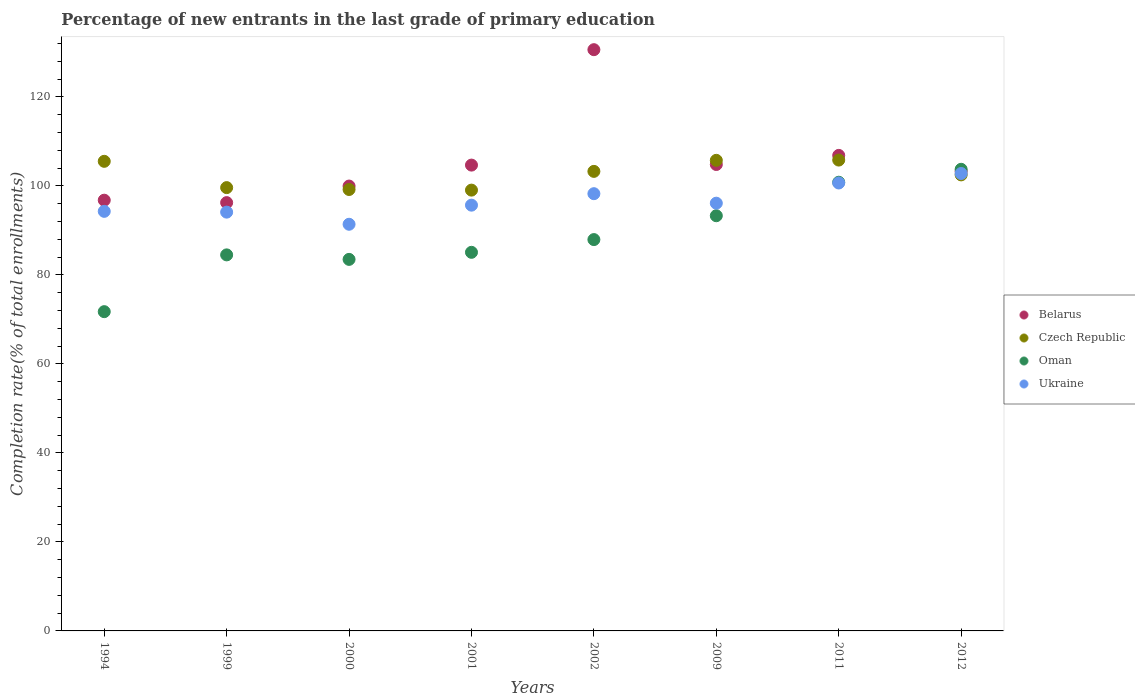Is the number of dotlines equal to the number of legend labels?
Your response must be concise. Yes. What is the percentage of new entrants in Oman in 2009?
Offer a very short reply. 93.29. Across all years, what is the maximum percentage of new entrants in Belarus?
Give a very brief answer. 130.61. Across all years, what is the minimum percentage of new entrants in Oman?
Provide a short and direct response. 71.74. In which year was the percentage of new entrants in Oman minimum?
Your response must be concise. 1994. What is the total percentage of new entrants in Belarus in the graph?
Offer a terse response. 843.21. What is the difference between the percentage of new entrants in Oman in 1999 and that in 2012?
Provide a succinct answer. -19.23. What is the difference between the percentage of new entrants in Belarus in 2000 and the percentage of new entrants in Ukraine in 2009?
Provide a succinct answer. 3.85. What is the average percentage of new entrants in Oman per year?
Your answer should be very brief. 88.82. In the year 2009, what is the difference between the percentage of new entrants in Oman and percentage of new entrants in Ukraine?
Offer a very short reply. -2.82. What is the ratio of the percentage of new entrants in Czech Republic in 2001 to that in 2002?
Give a very brief answer. 0.96. What is the difference between the highest and the second highest percentage of new entrants in Oman?
Your answer should be compact. 2.91. What is the difference between the highest and the lowest percentage of new entrants in Ukraine?
Your answer should be compact. 11.41. Is the sum of the percentage of new entrants in Belarus in 1994 and 2002 greater than the maximum percentage of new entrants in Czech Republic across all years?
Give a very brief answer. Yes. Is the percentage of new entrants in Belarus strictly greater than the percentage of new entrants in Oman over the years?
Provide a short and direct response. No. Does the graph contain any zero values?
Make the answer very short. No. Does the graph contain grids?
Provide a succinct answer. No. How are the legend labels stacked?
Keep it short and to the point. Vertical. What is the title of the graph?
Offer a very short reply. Percentage of new entrants in the last grade of primary education. Does "Maldives" appear as one of the legend labels in the graph?
Ensure brevity in your answer.  No. What is the label or title of the Y-axis?
Keep it short and to the point. Completion rate(% of total enrollments). What is the Completion rate(% of total enrollments) of Belarus in 1994?
Give a very brief answer. 96.79. What is the Completion rate(% of total enrollments) of Czech Republic in 1994?
Make the answer very short. 105.52. What is the Completion rate(% of total enrollments) of Oman in 1994?
Offer a terse response. 71.74. What is the Completion rate(% of total enrollments) in Ukraine in 1994?
Ensure brevity in your answer.  94.28. What is the Completion rate(% of total enrollments) of Belarus in 1999?
Provide a succinct answer. 96.24. What is the Completion rate(% of total enrollments) in Czech Republic in 1999?
Give a very brief answer. 99.61. What is the Completion rate(% of total enrollments) of Oman in 1999?
Ensure brevity in your answer.  84.5. What is the Completion rate(% of total enrollments) in Ukraine in 1999?
Keep it short and to the point. 94.1. What is the Completion rate(% of total enrollments) of Belarus in 2000?
Keep it short and to the point. 99.96. What is the Completion rate(% of total enrollments) of Czech Republic in 2000?
Offer a terse response. 99.19. What is the Completion rate(% of total enrollments) in Oman in 2000?
Keep it short and to the point. 83.49. What is the Completion rate(% of total enrollments) in Ukraine in 2000?
Your answer should be very brief. 91.38. What is the Completion rate(% of total enrollments) in Belarus in 2001?
Your response must be concise. 104.67. What is the Completion rate(% of total enrollments) of Czech Republic in 2001?
Provide a short and direct response. 99.05. What is the Completion rate(% of total enrollments) of Oman in 2001?
Your answer should be compact. 85.07. What is the Completion rate(% of total enrollments) in Ukraine in 2001?
Offer a very short reply. 95.67. What is the Completion rate(% of total enrollments) in Belarus in 2002?
Provide a short and direct response. 130.61. What is the Completion rate(% of total enrollments) in Czech Republic in 2002?
Provide a short and direct response. 103.26. What is the Completion rate(% of total enrollments) of Oman in 2002?
Offer a very short reply. 87.93. What is the Completion rate(% of total enrollments) of Ukraine in 2002?
Your response must be concise. 98.25. What is the Completion rate(% of total enrollments) of Belarus in 2009?
Offer a very short reply. 104.81. What is the Completion rate(% of total enrollments) in Czech Republic in 2009?
Offer a very short reply. 105.74. What is the Completion rate(% of total enrollments) of Oman in 2009?
Your response must be concise. 93.29. What is the Completion rate(% of total enrollments) in Ukraine in 2009?
Offer a very short reply. 96.11. What is the Completion rate(% of total enrollments) of Belarus in 2011?
Provide a succinct answer. 106.85. What is the Completion rate(% of total enrollments) in Czech Republic in 2011?
Provide a succinct answer. 105.8. What is the Completion rate(% of total enrollments) in Oman in 2011?
Offer a very short reply. 100.82. What is the Completion rate(% of total enrollments) of Ukraine in 2011?
Offer a very short reply. 100.65. What is the Completion rate(% of total enrollments) of Belarus in 2012?
Your answer should be very brief. 103.27. What is the Completion rate(% of total enrollments) of Czech Republic in 2012?
Offer a very short reply. 102.47. What is the Completion rate(% of total enrollments) in Oman in 2012?
Provide a succinct answer. 103.73. What is the Completion rate(% of total enrollments) of Ukraine in 2012?
Your response must be concise. 102.78. Across all years, what is the maximum Completion rate(% of total enrollments) in Belarus?
Offer a terse response. 130.61. Across all years, what is the maximum Completion rate(% of total enrollments) of Czech Republic?
Ensure brevity in your answer.  105.8. Across all years, what is the maximum Completion rate(% of total enrollments) in Oman?
Keep it short and to the point. 103.73. Across all years, what is the maximum Completion rate(% of total enrollments) in Ukraine?
Keep it short and to the point. 102.78. Across all years, what is the minimum Completion rate(% of total enrollments) of Belarus?
Keep it short and to the point. 96.24. Across all years, what is the minimum Completion rate(% of total enrollments) of Czech Republic?
Keep it short and to the point. 99.05. Across all years, what is the minimum Completion rate(% of total enrollments) in Oman?
Make the answer very short. 71.74. Across all years, what is the minimum Completion rate(% of total enrollments) in Ukraine?
Your answer should be very brief. 91.38. What is the total Completion rate(% of total enrollments) in Belarus in the graph?
Provide a succinct answer. 843.21. What is the total Completion rate(% of total enrollments) in Czech Republic in the graph?
Offer a terse response. 820.66. What is the total Completion rate(% of total enrollments) of Oman in the graph?
Provide a succinct answer. 710.58. What is the total Completion rate(% of total enrollments) of Ukraine in the graph?
Offer a very short reply. 773.23. What is the difference between the Completion rate(% of total enrollments) of Belarus in 1994 and that in 1999?
Provide a short and direct response. 0.55. What is the difference between the Completion rate(% of total enrollments) of Czech Republic in 1994 and that in 1999?
Provide a succinct answer. 5.91. What is the difference between the Completion rate(% of total enrollments) of Oman in 1994 and that in 1999?
Keep it short and to the point. -12.76. What is the difference between the Completion rate(% of total enrollments) of Ukraine in 1994 and that in 1999?
Your response must be concise. 0.18. What is the difference between the Completion rate(% of total enrollments) of Belarus in 1994 and that in 2000?
Ensure brevity in your answer.  -3.18. What is the difference between the Completion rate(% of total enrollments) in Czech Republic in 1994 and that in 2000?
Provide a succinct answer. 6.33. What is the difference between the Completion rate(% of total enrollments) in Oman in 1994 and that in 2000?
Offer a very short reply. -11.75. What is the difference between the Completion rate(% of total enrollments) of Ukraine in 1994 and that in 2000?
Your answer should be compact. 2.9. What is the difference between the Completion rate(% of total enrollments) of Belarus in 1994 and that in 2001?
Make the answer very short. -7.89. What is the difference between the Completion rate(% of total enrollments) in Czech Republic in 1994 and that in 2001?
Provide a succinct answer. 6.47. What is the difference between the Completion rate(% of total enrollments) in Oman in 1994 and that in 2001?
Your answer should be compact. -13.34. What is the difference between the Completion rate(% of total enrollments) of Ukraine in 1994 and that in 2001?
Offer a very short reply. -1.39. What is the difference between the Completion rate(% of total enrollments) in Belarus in 1994 and that in 2002?
Your response must be concise. -33.82. What is the difference between the Completion rate(% of total enrollments) of Czech Republic in 1994 and that in 2002?
Your response must be concise. 2.26. What is the difference between the Completion rate(% of total enrollments) of Oman in 1994 and that in 2002?
Offer a very short reply. -16.2. What is the difference between the Completion rate(% of total enrollments) of Ukraine in 1994 and that in 2002?
Your answer should be very brief. -3.97. What is the difference between the Completion rate(% of total enrollments) of Belarus in 1994 and that in 2009?
Provide a succinct answer. -8.02. What is the difference between the Completion rate(% of total enrollments) in Czech Republic in 1994 and that in 2009?
Your answer should be compact. -0.22. What is the difference between the Completion rate(% of total enrollments) in Oman in 1994 and that in 2009?
Your answer should be compact. -21.56. What is the difference between the Completion rate(% of total enrollments) in Ukraine in 1994 and that in 2009?
Your answer should be very brief. -1.83. What is the difference between the Completion rate(% of total enrollments) in Belarus in 1994 and that in 2011?
Give a very brief answer. -10.07. What is the difference between the Completion rate(% of total enrollments) of Czech Republic in 1994 and that in 2011?
Offer a very short reply. -0.28. What is the difference between the Completion rate(% of total enrollments) in Oman in 1994 and that in 2011?
Your answer should be very brief. -29.08. What is the difference between the Completion rate(% of total enrollments) in Ukraine in 1994 and that in 2011?
Provide a short and direct response. -6.37. What is the difference between the Completion rate(% of total enrollments) of Belarus in 1994 and that in 2012?
Provide a short and direct response. -6.49. What is the difference between the Completion rate(% of total enrollments) in Czech Republic in 1994 and that in 2012?
Your answer should be very brief. 3.05. What is the difference between the Completion rate(% of total enrollments) in Oman in 1994 and that in 2012?
Give a very brief answer. -31.99. What is the difference between the Completion rate(% of total enrollments) in Ukraine in 1994 and that in 2012?
Ensure brevity in your answer.  -8.5. What is the difference between the Completion rate(% of total enrollments) of Belarus in 1999 and that in 2000?
Your answer should be compact. -3.72. What is the difference between the Completion rate(% of total enrollments) of Czech Republic in 1999 and that in 2000?
Provide a succinct answer. 0.42. What is the difference between the Completion rate(% of total enrollments) in Oman in 1999 and that in 2000?
Keep it short and to the point. 1.01. What is the difference between the Completion rate(% of total enrollments) in Ukraine in 1999 and that in 2000?
Your response must be concise. 2.73. What is the difference between the Completion rate(% of total enrollments) of Belarus in 1999 and that in 2001?
Offer a very short reply. -8.43. What is the difference between the Completion rate(% of total enrollments) in Czech Republic in 1999 and that in 2001?
Provide a short and direct response. 0.56. What is the difference between the Completion rate(% of total enrollments) in Oman in 1999 and that in 2001?
Your answer should be very brief. -0.58. What is the difference between the Completion rate(% of total enrollments) of Ukraine in 1999 and that in 2001?
Your response must be concise. -1.57. What is the difference between the Completion rate(% of total enrollments) of Belarus in 1999 and that in 2002?
Make the answer very short. -34.37. What is the difference between the Completion rate(% of total enrollments) of Czech Republic in 1999 and that in 2002?
Your answer should be very brief. -3.65. What is the difference between the Completion rate(% of total enrollments) of Oman in 1999 and that in 2002?
Offer a terse response. -3.44. What is the difference between the Completion rate(% of total enrollments) in Ukraine in 1999 and that in 2002?
Give a very brief answer. -4.15. What is the difference between the Completion rate(% of total enrollments) of Belarus in 1999 and that in 2009?
Keep it short and to the point. -8.57. What is the difference between the Completion rate(% of total enrollments) in Czech Republic in 1999 and that in 2009?
Offer a terse response. -6.13. What is the difference between the Completion rate(% of total enrollments) of Oman in 1999 and that in 2009?
Provide a short and direct response. -8.8. What is the difference between the Completion rate(% of total enrollments) of Ukraine in 1999 and that in 2009?
Make the answer very short. -2.01. What is the difference between the Completion rate(% of total enrollments) of Belarus in 1999 and that in 2011?
Provide a succinct answer. -10.61. What is the difference between the Completion rate(% of total enrollments) in Czech Republic in 1999 and that in 2011?
Make the answer very short. -6.19. What is the difference between the Completion rate(% of total enrollments) of Oman in 1999 and that in 2011?
Your answer should be very brief. -16.32. What is the difference between the Completion rate(% of total enrollments) of Ukraine in 1999 and that in 2011?
Ensure brevity in your answer.  -6.55. What is the difference between the Completion rate(% of total enrollments) of Belarus in 1999 and that in 2012?
Give a very brief answer. -7.04. What is the difference between the Completion rate(% of total enrollments) in Czech Republic in 1999 and that in 2012?
Offer a very short reply. -2.86. What is the difference between the Completion rate(% of total enrollments) in Oman in 1999 and that in 2012?
Your response must be concise. -19.23. What is the difference between the Completion rate(% of total enrollments) in Ukraine in 1999 and that in 2012?
Your response must be concise. -8.68. What is the difference between the Completion rate(% of total enrollments) in Belarus in 2000 and that in 2001?
Your answer should be very brief. -4.71. What is the difference between the Completion rate(% of total enrollments) in Czech Republic in 2000 and that in 2001?
Provide a succinct answer. 0.14. What is the difference between the Completion rate(% of total enrollments) of Oman in 2000 and that in 2001?
Give a very brief answer. -1.59. What is the difference between the Completion rate(% of total enrollments) of Ukraine in 2000 and that in 2001?
Offer a very short reply. -4.29. What is the difference between the Completion rate(% of total enrollments) of Belarus in 2000 and that in 2002?
Offer a terse response. -30.65. What is the difference between the Completion rate(% of total enrollments) in Czech Republic in 2000 and that in 2002?
Give a very brief answer. -4.07. What is the difference between the Completion rate(% of total enrollments) of Oman in 2000 and that in 2002?
Make the answer very short. -4.45. What is the difference between the Completion rate(% of total enrollments) of Ukraine in 2000 and that in 2002?
Ensure brevity in your answer.  -6.87. What is the difference between the Completion rate(% of total enrollments) in Belarus in 2000 and that in 2009?
Give a very brief answer. -4.85. What is the difference between the Completion rate(% of total enrollments) in Czech Republic in 2000 and that in 2009?
Your response must be concise. -6.55. What is the difference between the Completion rate(% of total enrollments) of Oman in 2000 and that in 2009?
Your response must be concise. -9.81. What is the difference between the Completion rate(% of total enrollments) in Ukraine in 2000 and that in 2009?
Offer a terse response. -4.74. What is the difference between the Completion rate(% of total enrollments) in Belarus in 2000 and that in 2011?
Keep it short and to the point. -6.89. What is the difference between the Completion rate(% of total enrollments) in Czech Republic in 2000 and that in 2011?
Ensure brevity in your answer.  -6.61. What is the difference between the Completion rate(% of total enrollments) in Oman in 2000 and that in 2011?
Offer a very short reply. -17.34. What is the difference between the Completion rate(% of total enrollments) of Ukraine in 2000 and that in 2011?
Keep it short and to the point. -9.28. What is the difference between the Completion rate(% of total enrollments) of Belarus in 2000 and that in 2012?
Offer a very short reply. -3.31. What is the difference between the Completion rate(% of total enrollments) of Czech Republic in 2000 and that in 2012?
Ensure brevity in your answer.  -3.29. What is the difference between the Completion rate(% of total enrollments) in Oman in 2000 and that in 2012?
Keep it short and to the point. -20.24. What is the difference between the Completion rate(% of total enrollments) in Ukraine in 2000 and that in 2012?
Offer a terse response. -11.4. What is the difference between the Completion rate(% of total enrollments) in Belarus in 2001 and that in 2002?
Your answer should be compact. -25.94. What is the difference between the Completion rate(% of total enrollments) in Czech Republic in 2001 and that in 2002?
Your response must be concise. -4.21. What is the difference between the Completion rate(% of total enrollments) of Oman in 2001 and that in 2002?
Your answer should be very brief. -2.86. What is the difference between the Completion rate(% of total enrollments) of Ukraine in 2001 and that in 2002?
Provide a succinct answer. -2.58. What is the difference between the Completion rate(% of total enrollments) in Belarus in 2001 and that in 2009?
Your response must be concise. -0.14. What is the difference between the Completion rate(% of total enrollments) in Czech Republic in 2001 and that in 2009?
Keep it short and to the point. -6.69. What is the difference between the Completion rate(% of total enrollments) in Oman in 2001 and that in 2009?
Give a very brief answer. -8.22. What is the difference between the Completion rate(% of total enrollments) of Ukraine in 2001 and that in 2009?
Provide a succinct answer. -0.44. What is the difference between the Completion rate(% of total enrollments) of Belarus in 2001 and that in 2011?
Provide a short and direct response. -2.18. What is the difference between the Completion rate(% of total enrollments) of Czech Republic in 2001 and that in 2011?
Offer a terse response. -6.75. What is the difference between the Completion rate(% of total enrollments) in Oman in 2001 and that in 2011?
Provide a short and direct response. -15.75. What is the difference between the Completion rate(% of total enrollments) of Ukraine in 2001 and that in 2011?
Give a very brief answer. -4.98. What is the difference between the Completion rate(% of total enrollments) of Belarus in 2001 and that in 2012?
Offer a terse response. 1.4. What is the difference between the Completion rate(% of total enrollments) of Czech Republic in 2001 and that in 2012?
Ensure brevity in your answer.  -3.42. What is the difference between the Completion rate(% of total enrollments) of Oman in 2001 and that in 2012?
Make the answer very short. -18.66. What is the difference between the Completion rate(% of total enrollments) in Ukraine in 2001 and that in 2012?
Your answer should be compact. -7.11. What is the difference between the Completion rate(% of total enrollments) in Belarus in 2002 and that in 2009?
Provide a short and direct response. 25.8. What is the difference between the Completion rate(% of total enrollments) in Czech Republic in 2002 and that in 2009?
Make the answer very short. -2.48. What is the difference between the Completion rate(% of total enrollments) of Oman in 2002 and that in 2009?
Keep it short and to the point. -5.36. What is the difference between the Completion rate(% of total enrollments) in Ukraine in 2002 and that in 2009?
Your answer should be very brief. 2.13. What is the difference between the Completion rate(% of total enrollments) of Belarus in 2002 and that in 2011?
Offer a very short reply. 23.76. What is the difference between the Completion rate(% of total enrollments) of Czech Republic in 2002 and that in 2011?
Provide a short and direct response. -2.54. What is the difference between the Completion rate(% of total enrollments) in Oman in 2002 and that in 2011?
Keep it short and to the point. -12.89. What is the difference between the Completion rate(% of total enrollments) in Ukraine in 2002 and that in 2011?
Offer a very short reply. -2.4. What is the difference between the Completion rate(% of total enrollments) in Belarus in 2002 and that in 2012?
Your answer should be compact. 27.33. What is the difference between the Completion rate(% of total enrollments) in Czech Republic in 2002 and that in 2012?
Make the answer very short. 0.79. What is the difference between the Completion rate(% of total enrollments) of Oman in 2002 and that in 2012?
Make the answer very short. -15.8. What is the difference between the Completion rate(% of total enrollments) in Ukraine in 2002 and that in 2012?
Offer a terse response. -4.53. What is the difference between the Completion rate(% of total enrollments) in Belarus in 2009 and that in 2011?
Your answer should be compact. -2.04. What is the difference between the Completion rate(% of total enrollments) in Czech Republic in 2009 and that in 2011?
Provide a short and direct response. -0.06. What is the difference between the Completion rate(% of total enrollments) in Oman in 2009 and that in 2011?
Your answer should be compact. -7.53. What is the difference between the Completion rate(% of total enrollments) in Ukraine in 2009 and that in 2011?
Your response must be concise. -4.54. What is the difference between the Completion rate(% of total enrollments) in Belarus in 2009 and that in 2012?
Give a very brief answer. 1.53. What is the difference between the Completion rate(% of total enrollments) in Czech Republic in 2009 and that in 2012?
Your answer should be very brief. 3.27. What is the difference between the Completion rate(% of total enrollments) in Oman in 2009 and that in 2012?
Provide a short and direct response. -10.44. What is the difference between the Completion rate(% of total enrollments) in Ukraine in 2009 and that in 2012?
Offer a terse response. -6.67. What is the difference between the Completion rate(% of total enrollments) in Belarus in 2011 and that in 2012?
Your answer should be very brief. 3.58. What is the difference between the Completion rate(% of total enrollments) of Czech Republic in 2011 and that in 2012?
Provide a succinct answer. 3.33. What is the difference between the Completion rate(% of total enrollments) of Oman in 2011 and that in 2012?
Ensure brevity in your answer.  -2.91. What is the difference between the Completion rate(% of total enrollments) of Ukraine in 2011 and that in 2012?
Offer a terse response. -2.13. What is the difference between the Completion rate(% of total enrollments) of Belarus in 1994 and the Completion rate(% of total enrollments) of Czech Republic in 1999?
Ensure brevity in your answer.  -2.83. What is the difference between the Completion rate(% of total enrollments) of Belarus in 1994 and the Completion rate(% of total enrollments) of Oman in 1999?
Your answer should be very brief. 12.29. What is the difference between the Completion rate(% of total enrollments) in Belarus in 1994 and the Completion rate(% of total enrollments) in Ukraine in 1999?
Ensure brevity in your answer.  2.68. What is the difference between the Completion rate(% of total enrollments) in Czech Republic in 1994 and the Completion rate(% of total enrollments) in Oman in 1999?
Make the answer very short. 21.02. What is the difference between the Completion rate(% of total enrollments) in Czech Republic in 1994 and the Completion rate(% of total enrollments) in Ukraine in 1999?
Your answer should be very brief. 11.42. What is the difference between the Completion rate(% of total enrollments) in Oman in 1994 and the Completion rate(% of total enrollments) in Ukraine in 1999?
Offer a very short reply. -22.36. What is the difference between the Completion rate(% of total enrollments) of Belarus in 1994 and the Completion rate(% of total enrollments) of Czech Republic in 2000?
Keep it short and to the point. -2.4. What is the difference between the Completion rate(% of total enrollments) in Belarus in 1994 and the Completion rate(% of total enrollments) in Oman in 2000?
Your response must be concise. 13.3. What is the difference between the Completion rate(% of total enrollments) in Belarus in 1994 and the Completion rate(% of total enrollments) in Ukraine in 2000?
Provide a short and direct response. 5.41. What is the difference between the Completion rate(% of total enrollments) in Czech Republic in 1994 and the Completion rate(% of total enrollments) in Oman in 2000?
Make the answer very short. 22.03. What is the difference between the Completion rate(% of total enrollments) of Czech Republic in 1994 and the Completion rate(% of total enrollments) of Ukraine in 2000?
Offer a very short reply. 14.14. What is the difference between the Completion rate(% of total enrollments) in Oman in 1994 and the Completion rate(% of total enrollments) in Ukraine in 2000?
Keep it short and to the point. -19.64. What is the difference between the Completion rate(% of total enrollments) in Belarus in 1994 and the Completion rate(% of total enrollments) in Czech Republic in 2001?
Ensure brevity in your answer.  -2.26. What is the difference between the Completion rate(% of total enrollments) in Belarus in 1994 and the Completion rate(% of total enrollments) in Oman in 2001?
Give a very brief answer. 11.71. What is the difference between the Completion rate(% of total enrollments) in Belarus in 1994 and the Completion rate(% of total enrollments) in Ukraine in 2001?
Provide a short and direct response. 1.12. What is the difference between the Completion rate(% of total enrollments) in Czech Republic in 1994 and the Completion rate(% of total enrollments) in Oman in 2001?
Your response must be concise. 20.45. What is the difference between the Completion rate(% of total enrollments) in Czech Republic in 1994 and the Completion rate(% of total enrollments) in Ukraine in 2001?
Keep it short and to the point. 9.85. What is the difference between the Completion rate(% of total enrollments) in Oman in 1994 and the Completion rate(% of total enrollments) in Ukraine in 2001?
Your response must be concise. -23.93. What is the difference between the Completion rate(% of total enrollments) in Belarus in 1994 and the Completion rate(% of total enrollments) in Czech Republic in 2002?
Give a very brief answer. -6.47. What is the difference between the Completion rate(% of total enrollments) in Belarus in 1994 and the Completion rate(% of total enrollments) in Oman in 2002?
Offer a very short reply. 8.85. What is the difference between the Completion rate(% of total enrollments) of Belarus in 1994 and the Completion rate(% of total enrollments) of Ukraine in 2002?
Keep it short and to the point. -1.46. What is the difference between the Completion rate(% of total enrollments) of Czech Republic in 1994 and the Completion rate(% of total enrollments) of Oman in 2002?
Your answer should be very brief. 17.59. What is the difference between the Completion rate(% of total enrollments) of Czech Republic in 1994 and the Completion rate(% of total enrollments) of Ukraine in 2002?
Give a very brief answer. 7.27. What is the difference between the Completion rate(% of total enrollments) of Oman in 1994 and the Completion rate(% of total enrollments) of Ukraine in 2002?
Keep it short and to the point. -26.51. What is the difference between the Completion rate(% of total enrollments) of Belarus in 1994 and the Completion rate(% of total enrollments) of Czech Republic in 2009?
Give a very brief answer. -8.96. What is the difference between the Completion rate(% of total enrollments) of Belarus in 1994 and the Completion rate(% of total enrollments) of Oman in 2009?
Offer a very short reply. 3.49. What is the difference between the Completion rate(% of total enrollments) of Belarus in 1994 and the Completion rate(% of total enrollments) of Ukraine in 2009?
Make the answer very short. 0.67. What is the difference between the Completion rate(% of total enrollments) of Czech Republic in 1994 and the Completion rate(% of total enrollments) of Oman in 2009?
Provide a short and direct response. 12.23. What is the difference between the Completion rate(% of total enrollments) in Czech Republic in 1994 and the Completion rate(% of total enrollments) in Ukraine in 2009?
Provide a succinct answer. 9.41. What is the difference between the Completion rate(% of total enrollments) in Oman in 1994 and the Completion rate(% of total enrollments) in Ukraine in 2009?
Your answer should be very brief. -24.38. What is the difference between the Completion rate(% of total enrollments) in Belarus in 1994 and the Completion rate(% of total enrollments) in Czech Republic in 2011?
Ensure brevity in your answer.  -9.02. What is the difference between the Completion rate(% of total enrollments) of Belarus in 1994 and the Completion rate(% of total enrollments) of Oman in 2011?
Provide a short and direct response. -4.04. What is the difference between the Completion rate(% of total enrollments) in Belarus in 1994 and the Completion rate(% of total enrollments) in Ukraine in 2011?
Your response must be concise. -3.87. What is the difference between the Completion rate(% of total enrollments) of Czech Republic in 1994 and the Completion rate(% of total enrollments) of Oman in 2011?
Your answer should be very brief. 4.7. What is the difference between the Completion rate(% of total enrollments) in Czech Republic in 1994 and the Completion rate(% of total enrollments) in Ukraine in 2011?
Provide a succinct answer. 4.87. What is the difference between the Completion rate(% of total enrollments) of Oman in 1994 and the Completion rate(% of total enrollments) of Ukraine in 2011?
Offer a very short reply. -28.91. What is the difference between the Completion rate(% of total enrollments) of Belarus in 1994 and the Completion rate(% of total enrollments) of Czech Republic in 2012?
Your answer should be very brief. -5.69. What is the difference between the Completion rate(% of total enrollments) in Belarus in 1994 and the Completion rate(% of total enrollments) in Oman in 2012?
Your answer should be very brief. -6.94. What is the difference between the Completion rate(% of total enrollments) of Belarus in 1994 and the Completion rate(% of total enrollments) of Ukraine in 2012?
Your answer should be very brief. -6. What is the difference between the Completion rate(% of total enrollments) in Czech Republic in 1994 and the Completion rate(% of total enrollments) in Oman in 2012?
Give a very brief answer. 1.79. What is the difference between the Completion rate(% of total enrollments) of Czech Republic in 1994 and the Completion rate(% of total enrollments) of Ukraine in 2012?
Provide a short and direct response. 2.74. What is the difference between the Completion rate(% of total enrollments) in Oman in 1994 and the Completion rate(% of total enrollments) in Ukraine in 2012?
Keep it short and to the point. -31.04. What is the difference between the Completion rate(% of total enrollments) in Belarus in 1999 and the Completion rate(% of total enrollments) in Czech Republic in 2000?
Your answer should be compact. -2.95. What is the difference between the Completion rate(% of total enrollments) in Belarus in 1999 and the Completion rate(% of total enrollments) in Oman in 2000?
Provide a succinct answer. 12.75. What is the difference between the Completion rate(% of total enrollments) of Belarus in 1999 and the Completion rate(% of total enrollments) of Ukraine in 2000?
Ensure brevity in your answer.  4.86. What is the difference between the Completion rate(% of total enrollments) of Czech Republic in 1999 and the Completion rate(% of total enrollments) of Oman in 2000?
Provide a short and direct response. 16.13. What is the difference between the Completion rate(% of total enrollments) in Czech Republic in 1999 and the Completion rate(% of total enrollments) in Ukraine in 2000?
Your answer should be compact. 8.24. What is the difference between the Completion rate(% of total enrollments) of Oman in 1999 and the Completion rate(% of total enrollments) of Ukraine in 2000?
Offer a very short reply. -6.88. What is the difference between the Completion rate(% of total enrollments) in Belarus in 1999 and the Completion rate(% of total enrollments) in Czech Republic in 2001?
Your answer should be very brief. -2.81. What is the difference between the Completion rate(% of total enrollments) of Belarus in 1999 and the Completion rate(% of total enrollments) of Oman in 2001?
Ensure brevity in your answer.  11.16. What is the difference between the Completion rate(% of total enrollments) of Belarus in 1999 and the Completion rate(% of total enrollments) of Ukraine in 2001?
Provide a succinct answer. 0.57. What is the difference between the Completion rate(% of total enrollments) in Czech Republic in 1999 and the Completion rate(% of total enrollments) in Oman in 2001?
Give a very brief answer. 14.54. What is the difference between the Completion rate(% of total enrollments) of Czech Republic in 1999 and the Completion rate(% of total enrollments) of Ukraine in 2001?
Your answer should be compact. 3.94. What is the difference between the Completion rate(% of total enrollments) in Oman in 1999 and the Completion rate(% of total enrollments) in Ukraine in 2001?
Provide a short and direct response. -11.17. What is the difference between the Completion rate(% of total enrollments) of Belarus in 1999 and the Completion rate(% of total enrollments) of Czech Republic in 2002?
Provide a succinct answer. -7.02. What is the difference between the Completion rate(% of total enrollments) of Belarus in 1999 and the Completion rate(% of total enrollments) of Oman in 2002?
Your answer should be compact. 8.3. What is the difference between the Completion rate(% of total enrollments) in Belarus in 1999 and the Completion rate(% of total enrollments) in Ukraine in 2002?
Ensure brevity in your answer.  -2.01. What is the difference between the Completion rate(% of total enrollments) of Czech Republic in 1999 and the Completion rate(% of total enrollments) of Oman in 2002?
Offer a very short reply. 11.68. What is the difference between the Completion rate(% of total enrollments) of Czech Republic in 1999 and the Completion rate(% of total enrollments) of Ukraine in 2002?
Keep it short and to the point. 1.36. What is the difference between the Completion rate(% of total enrollments) in Oman in 1999 and the Completion rate(% of total enrollments) in Ukraine in 2002?
Provide a short and direct response. -13.75. What is the difference between the Completion rate(% of total enrollments) in Belarus in 1999 and the Completion rate(% of total enrollments) in Czech Republic in 2009?
Ensure brevity in your answer.  -9.51. What is the difference between the Completion rate(% of total enrollments) of Belarus in 1999 and the Completion rate(% of total enrollments) of Oman in 2009?
Make the answer very short. 2.94. What is the difference between the Completion rate(% of total enrollments) in Belarus in 1999 and the Completion rate(% of total enrollments) in Ukraine in 2009?
Your response must be concise. 0.12. What is the difference between the Completion rate(% of total enrollments) in Czech Republic in 1999 and the Completion rate(% of total enrollments) in Oman in 2009?
Your response must be concise. 6.32. What is the difference between the Completion rate(% of total enrollments) of Czech Republic in 1999 and the Completion rate(% of total enrollments) of Ukraine in 2009?
Your response must be concise. 3.5. What is the difference between the Completion rate(% of total enrollments) of Oman in 1999 and the Completion rate(% of total enrollments) of Ukraine in 2009?
Your response must be concise. -11.62. What is the difference between the Completion rate(% of total enrollments) in Belarus in 1999 and the Completion rate(% of total enrollments) in Czech Republic in 2011?
Provide a short and direct response. -9.56. What is the difference between the Completion rate(% of total enrollments) of Belarus in 1999 and the Completion rate(% of total enrollments) of Oman in 2011?
Give a very brief answer. -4.58. What is the difference between the Completion rate(% of total enrollments) of Belarus in 1999 and the Completion rate(% of total enrollments) of Ukraine in 2011?
Make the answer very short. -4.41. What is the difference between the Completion rate(% of total enrollments) in Czech Republic in 1999 and the Completion rate(% of total enrollments) in Oman in 2011?
Your answer should be very brief. -1.21. What is the difference between the Completion rate(% of total enrollments) of Czech Republic in 1999 and the Completion rate(% of total enrollments) of Ukraine in 2011?
Your answer should be very brief. -1.04. What is the difference between the Completion rate(% of total enrollments) in Oman in 1999 and the Completion rate(% of total enrollments) in Ukraine in 2011?
Give a very brief answer. -16.15. What is the difference between the Completion rate(% of total enrollments) in Belarus in 1999 and the Completion rate(% of total enrollments) in Czech Republic in 2012?
Your answer should be very brief. -6.24. What is the difference between the Completion rate(% of total enrollments) of Belarus in 1999 and the Completion rate(% of total enrollments) of Oman in 2012?
Ensure brevity in your answer.  -7.49. What is the difference between the Completion rate(% of total enrollments) in Belarus in 1999 and the Completion rate(% of total enrollments) in Ukraine in 2012?
Offer a terse response. -6.54. What is the difference between the Completion rate(% of total enrollments) in Czech Republic in 1999 and the Completion rate(% of total enrollments) in Oman in 2012?
Your answer should be compact. -4.12. What is the difference between the Completion rate(% of total enrollments) of Czech Republic in 1999 and the Completion rate(% of total enrollments) of Ukraine in 2012?
Your answer should be very brief. -3.17. What is the difference between the Completion rate(% of total enrollments) in Oman in 1999 and the Completion rate(% of total enrollments) in Ukraine in 2012?
Give a very brief answer. -18.28. What is the difference between the Completion rate(% of total enrollments) of Belarus in 2000 and the Completion rate(% of total enrollments) of Czech Republic in 2001?
Give a very brief answer. 0.91. What is the difference between the Completion rate(% of total enrollments) of Belarus in 2000 and the Completion rate(% of total enrollments) of Oman in 2001?
Give a very brief answer. 14.89. What is the difference between the Completion rate(% of total enrollments) in Belarus in 2000 and the Completion rate(% of total enrollments) in Ukraine in 2001?
Your response must be concise. 4.29. What is the difference between the Completion rate(% of total enrollments) in Czech Republic in 2000 and the Completion rate(% of total enrollments) in Oman in 2001?
Provide a short and direct response. 14.12. What is the difference between the Completion rate(% of total enrollments) of Czech Republic in 2000 and the Completion rate(% of total enrollments) of Ukraine in 2001?
Your response must be concise. 3.52. What is the difference between the Completion rate(% of total enrollments) in Oman in 2000 and the Completion rate(% of total enrollments) in Ukraine in 2001?
Offer a terse response. -12.19. What is the difference between the Completion rate(% of total enrollments) of Belarus in 2000 and the Completion rate(% of total enrollments) of Czech Republic in 2002?
Your answer should be compact. -3.3. What is the difference between the Completion rate(% of total enrollments) in Belarus in 2000 and the Completion rate(% of total enrollments) in Oman in 2002?
Provide a succinct answer. 12.03. What is the difference between the Completion rate(% of total enrollments) in Belarus in 2000 and the Completion rate(% of total enrollments) in Ukraine in 2002?
Your answer should be compact. 1.71. What is the difference between the Completion rate(% of total enrollments) of Czech Republic in 2000 and the Completion rate(% of total enrollments) of Oman in 2002?
Keep it short and to the point. 11.26. What is the difference between the Completion rate(% of total enrollments) in Czech Republic in 2000 and the Completion rate(% of total enrollments) in Ukraine in 2002?
Give a very brief answer. 0.94. What is the difference between the Completion rate(% of total enrollments) in Oman in 2000 and the Completion rate(% of total enrollments) in Ukraine in 2002?
Provide a succinct answer. -14.76. What is the difference between the Completion rate(% of total enrollments) in Belarus in 2000 and the Completion rate(% of total enrollments) in Czech Republic in 2009?
Provide a short and direct response. -5.78. What is the difference between the Completion rate(% of total enrollments) of Belarus in 2000 and the Completion rate(% of total enrollments) of Oman in 2009?
Your answer should be compact. 6.67. What is the difference between the Completion rate(% of total enrollments) in Belarus in 2000 and the Completion rate(% of total enrollments) in Ukraine in 2009?
Offer a terse response. 3.85. What is the difference between the Completion rate(% of total enrollments) in Czech Republic in 2000 and the Completion rate(% of total enrollments) in Oman in 2009?
Your answer should be compact. 5.9. What is the difference between the Completion rate(% of total enrollments) in Czech Republic in 2000 and the Completion rate(% of total enrollments) in Ukraine in 2009?
Keep it short and to the point. 3.08. What is the difference between the Completion rate(% of total enrollments) of Oman in 2000 and the Completion rate(% of total enrollments) of Ukraine in 2009?
Give a very brief answer. -12.63. What is the difference between the Completion rate(% of total enrollments) of Belarus in 2000 and the Completion rate(% of total enrollments) of Czech Republic in 2011?
Make the answer very short. -5.84. What is the difference between the Completion rate(% of total enrollments) in Belarus in 2000 and the Completion rate(% of total enrollments) in Oman in 2011?
Your response must be concise. -0.86. What is the difference between the Completion rate(% of total enrollments) of Belarus in 2000 and the Completion rate(% of total enrollments) of Ukraine in 2011?
Offer a terse response. -0.69. What is the difference between the Completion rate(% of total enrollments) in Czech Republic in 2000 and the Completion rate(% of total enrollments) in Oman in 2011?
Provide a succinct answer. -1.63. What is the difference between the Completion rate(% of total enrollments) in Czech Republic in 2000 and the Completion rate(% of total enrollments) in Ukraine in 2011?
Make the answer very short. -1.46. What is the difference between the Completion rate(% of total enrollments) in Oman in 2000 and the Completion rate(% of total enrollments) in Ukraine in 2011?
Your answer should be very brief. -17.17. What is the difference between the Completion rate(% of total enrollments) in Belarus in 2000 and the Completion rate(% of total enrollments) in Czech Republic in 2012?
Provide a short and direct response. -2.51. What is the difference between the Completion rate(% of total enrollments) of Belarus in 2000 and the Completion rate(% of total enrollments) of Oman in 2012?
Your response must be concise. -3.77. What is the difference between the Completion rate(% of total enrollments) in Belarus in 2000 and the Completion rate(% of total enrollments) in Ukraine in 2012?
Make the answer very short. -2.82. What is the difference between the Completion rate(% of total enrollments) of Czech Republic in 2000 and the Completion rate(% of total enrollments) of Oman in 2012?
Offer a terse response. -4.54. What is the difference between the Completion rate(% of total enrollments) in Czech Republic in 2000 and the Completion rate(% of total enrollments) in Ukraine in 2012?
Make the answer very short. -3.59. What is the difference between the Completion rate(% of total enrollments) in Oman in 2000 and the Completion rate(% of total enrollments) in Ukraine in 2012?
Provide a succinct answer. -19.3. What is the difference between the Completion rate(% of total enrollments) in Belarus in 2001 and the Completion rate(% of total enrollments) in Czech Republic in 2002?
Make the answer very short. 1.41. What is the difference between the Completion rate(% of total enrollments) of Belarus in 2001 and the Completion rate(% of total enrollments) of Oman in 2002?
Give a very brief answer. 16.74. What is the difference between the Completion rate(% of total enrollments) in Belarus in 2001 and the Completion rate(% of total enrollments) in Ukraine in 2002?
Provide a succinct answer. 6.42. What is the difference between the Completion rate(% of total enrollments) in Czech Republic in 2001 and the Completion rate(% of total enrollments) in Oman in 2002?
Keep it short and to the point. 11.12. What is the difference between the Completion rate(% of total enrollments) in Czech Republic in 2001 and the Completion rate(% of total enrollments) in Ukraine in 2002?
Provide a short and direct response. 0.8. What is the difference between the Completion rate(% of total enrollments) in Oman in 2001 and the Completion rate(% of total enrollments) in Ukraine in 2002?
Ensure brevity in your answer.  -13.17. What is the difference between the Completion rate(% of total enrollments) in Belarus in 2001 and the Completion rate(% of total enrollments) in Czech Republic in 2009?
Offer a very short reply. -1.07. What is the difference between the Completion rate(% of total enrollments) of Belarus in 2001 and the Completion rate(% of total enrollments) of Oman in 2009?
Make the answer very short. 11.38. What is the difference between the Completion rate(% of total enrollments) in Belarus in 2001 and the Completion rate(% of total enrollments) in Ukraine in 2009?
Make the answer very short. 8.56. What is the difference between the Completion rate(% of total enrollments) of Czech Republic in 2001 and the Completion rate(% of total enrollments) of Oman in 2009?
Ensure brevity in your answer.  5.76. What is the difference between the Completion rate(% of total enrollments) of Czech Republic in 2001 and the Completion rate(% of total enrollments) of Ukraine in 2009?
Your answer should be compact. 2.94. What is the difference between the Completion rate(% of total enrollments) of Oman in 2001 and the Completion rate(% of total enrollments) of Ukraine in 2009?
Provide a succinct answer. -11.04. What is the difference between the Completion rate(% of total enrollments) of Belarus in 2001 and the Completion rate(% of total enrollments) of Czech Republic in 2011?
Ensure brevity in your answer.  -1.13. What is the difference between the Completion rate(% of total enrollments) in Belarus in 2001 and the Completion rate(% of total enrollments) in Oman in 2011?
Your answer should be very brief. 3.85. What is the difference between the Completion rate(% of total enrollments) in Belarus in 2001 and the Completion rate(% of total enrollments) in Ukraine in 2011?
Provide a short and direct response. 4.02. What is the difference between the Completion rate(% of total enrollments) of Czech Republic in 2001 and the Completion rate(% of total enrollments) of Oman in 2011?
Your answer should be very brief. -1.77. What is the difference between the Completion rate(% of total enrollments) in Czech Republic in 2001 and the Completion rate(% of total enrollments) in Ukraine in 2011?
Give a very brief answer. -1.6. What is the difference between the Completion rate(% of total enrollments) of Oman in 2001 and the Completion rate(% of total enrollments) of Ukraine in 2011?
Make the answer very short. -15.58. What is the difference between the Completion rate(% of total enrollments) in Belarus in 2001 and the Completion rate(% of total enrollments) in Czech Republic in 2012?
Ensure brevity in your answer.  2.2. What is the difference between the Completion rate(% of total enrollments) of Belarus in 2001 and the Completion rate(% of total enrollments) of Oman in 2012?
Ensure brevity in your answer.  0.94. What is the difference between the Completion rate(% of total enrollments) in Belarus in 2001 and the Completion rate(% of total enrollments) in Ukraine in 2012?
Your response must be concise. 1.89. What is the difference between the Completion rate(% of total enrollments) of Czech Republic in 2001 and the Completion rate(% of total enrollments) of Oman in 2012?
Provide a short and direct response. -4.68. What is the difference between the Completion rate(% of total enrollments) of Czech Republic in 2001 and the Completion rate(% of total enrollments) of Ukraine in 2012?
Your response must be concise. -3.73. What is the difference between the Completion rate(% of total enrollments) of Oman in 2001 and the Completion rate(% of total enrollments) of Ukraine in 2012?
Provide a short and direct response. -17.71. What is the difference between the Completion rate(% of total enrollments) of Belarus in 2002 and the Completion rate(% of total enrollments) of Czech Republic in 2009?
Provide a short and direct response. 24.86. What is the difference between the Completion rate(% of total enrollments) of Belarus in 2002 and the Completion rate(% of total enrollments) of Oman in 2009?
Offer a terse response. 37.31. What is the difference between the Completion rate(% of total enrollments) of Belarus in 2002 and the Completion rate(% of total enrollments) of Ukraine in 2009?
Make the answer very short. 34.49. What is the difference between the Completion rate(% of total enrollments) in Czech Republic in 2002 and the Completion rate(% of total enrollments) in Oman in 2009?
Offer a very short reply. 9.97. What is the difference between the Completion rate(% of total enrollments) of Czech Republic in 2002 and the Completion rate(% of total enrollments) of Ukraine in 2009?
Ensure brevity in your answer.  7.15. What is the difference between the Completion rate(% of total enrollments) in Oman in 2002 and the Completion rate(% of total enrollments) in Ukraine in 2009?
Your response must be concise. -8.18. What is the difference between the Completion rate(% of total enrollments) of Belarus in 2002 and the Completion rate(% of total enrollments) of Czech Republic in 2011?
Provide a short and direct response. 24.81. What is the difference between the Completion rate(% of total enrollments) of Belarus in 2002 and the Completion rate(% of total enrollments) of Oman in 2011?
Offer a very short reply. 29.79. What is the difference between the Completion rate(% of total enrollments) of Belarus in 2002 and the Completion rate(% of total enrollments) of Ukraine in 2011?
Provide a short and direct response. 29.96. What is the difference between the Completion rate(% of total enrollments) of Czech Republic in 2002 and the Completion rate(% of total enrollments) of Oman in 2011?
Ensure brevity in your answer.  2.44. What is the difference between the Completion rate(% of total enrollments) in Czech Republic in 2002 and the Completion rate(% of total enrollments) in Ukraine in 2011?
Ensure brevity in your answer.  2.61. What is the difference between the Completion rate(% of total enrollments) of Oman in 2002 and the Completion rate(% of total enrollments) of Ukraine in 2011?
Make the answer very short. -12.72. What is the difference between the Completion rate(% of total enrollments) of Belarus in 2002 and the Completion rate(% of total enrollments) of Czech Republic in 2012?
Provide a succinct answer. 28.13. What is the difference between the Completion rate(% of total enrollments) of Belarus in 2002 and the Completion rate(% of total enrollments) of Oman in 2012?
Make the answer very short. 26.88. What is the difference between the Completion rate(% of total enrollments) of Belarus in 2002 and the Completion rate(% of total enrollments) of Ukraine in 2012?
Offer a very short reply. 27.83. What is the difference between the Completion rate(% of total enrollments) in Czech Republic in 2002 and the Completion rate(% of total enrollments) in Oman in 2012?
Your answer should be compact. -0.47. What is the difference between the Completion rate(% of total enrollments) of Czech Republic in 2002 and the Completion rate(% of total enrollments) of Ukraine in 2012?
Provide a short and direct response. 0.48. What is the difference between the Completion rate(% of total enrollments) in Oman in 2002 and the Completion rate(% of total enrollments) in Ukraine in 2012?
Ensure brevity in your answer.  -14.85. What is the difference between the Completion rate(% of total enrollments) in Belarus in 2009 and the Completion rate(% of total enrollments) in Czech Republic in 2011?
Give a very brief answer. -0.99. What is the difference between the Completion rate(% of total enrollments) in Belarus in 2009 and the Completion rate(% of total enrollments) in Oman in 2011?
Ensure brevity in your answer.  3.99. What is the difference between the Completion rate(% of total enrollments) of Belarus in 2009 and the Completion rate(% of total enrollments) of Ukraine in 2011?
Provide a succinct answer. 4.16. What is the difference between the Completion rate(% of total enrollments) in Czech Republic in 2009 and the Completion rate(% of total enrollments) in Oman in 2011?
Your response must be concise. 4.92. What is the difference between the Completion rate(% of total enrollments) in Czech Republic in 2009 and the Completion rate(% of total enrollments) in Ukraine in 2011?
Provide a short and direct response. 5.09. What is the difference between the Completion rate(% of total enrollments) of Oman in 2009 and the Completion rate(% of total enrollments) of Ukraine in 2011?
Give a very brief answer. -7.36. What is the difference between the Completion rate(% of total enrollments) in Belarus in 2009 and the Completion rate(% of total enrollments) in Czech Republic in 2012?
Your answer should be very brief. 2.33. What is the difference between the Completion rate(% of total enrollments) in Belarus in 2009 and the Completion rate(% of total enrollments) in Oman in 2012?
Ensure brevity in your answer.  1.08. What is the difference between the Completion rate(% of total enrollments) in Belarus in 2009 and the Completion rate(% of total enrollments) in Ukraine in 2012?
Keep it short and to the point. 2.03. What is the difference between the Completion rate(% of total enrollments) in Czech Republic in 2009 and the Completion rate(% of total enrollments) in Oman in 2012?
Provide a short and direct response. 2.01. What is the difference between the Completion rate(% of total enrollments) in Czech Republic in 2009 and the Completion rate(% of total enrollments) in Ukraine in 2012?
Your response must be concise. 2.96. What is the difference between the Completion rate(% of total enrollments) in Oman in 2009 and the Completion rate(% of total enrollments) in Ukraine in 2012?
Provide a short and direct response. -9.49. What is the difference between the Completion rate(% of total enrollments) in Belarus in 2011 and the Completion rate(% of total enrollments) in Czech Republic in 2012?
Provide a succinct answer. 4.38. What is the difference between the Completion rate(% of total enrollments) in Belarus in 2011 and the Completion rate(% of total enrollments) in Oman in 2012?
Your response must be concise. 3.12. What is the difference between the Completion rate(% of total enrollments) in Belarus in 2011 and the Completion rate(% of total enrollments) in Ukraine in 2012?
Provide a short and direct response. 4.07. What is the difference between the Completion rate(% of total enrollments) in Czech Republic in 2011 and the Completion rate(% of total enrollments) in Oman in 2012?
Give a very brief answer. 2.07. What is the difference between the Completion rate(% of total enrollments) of Czech Republic in 2011 and the Completion rate(% of total enrollments) of Ukraine in 2012?
Keep it short and to the point. 3.02. What is the difference between the Completion rate(% of total enrollments) in Oman in 2011 and the Completion rate(% of total enrollments) in Ukraine in 2012?
Your response must be concise. -1.96. What is the average Completion rate(% of total enrollments) in Belarus per year?
Your answer should be compact. 105.4. What is the average Completion rate(% of total enrollments) in Czech Republic per year?
Keep it short and to the point. 102.58. What is the average Completion rate(% of total enrollments) of Oman per year?
Your answer should be very brief. 88.82. What is the average Completion rate(% of total enrollments) of Ukraine per year?
Provide a short and direct response. 96.65. In the year 1994, what is the difference between the Completion rate(% of total enrollments) of Belarus and Completion rate(% of total enrollments) of Czech Republic?
Your answer should be compact. -8.73. In the year 1994, what is the difference between the Completion rate(% of total enrollments) of Belarus and Completion rate(% of total enrollments) of Oman?
Ensure brevity in your answer.  25.05. In the year 1994, what is the difference between the Completion rate(% of total enrollments) in Belarus and Completion rate(% of total enrollments) in Ukraine?
Make the answer very short. 2.51. In the year 1994, what is the difference between the Completion rate(% of total enrollments) in Czech Republic and Completion rate(% of total enrollments) in Oman?
Keep it short and to the point. 33.78. In the year 1994, what is the difference between the Completion rate(% of total enrollments) in Czech Republic and Completion rate(% of total enrollments) in Ukraine?
Give a very brief answer. 11.24. In the year 1994, what is the difference between the Completion rate(% of total enrollments) of Oman and Completion rate(% of total enrollments) of Ukraine?
Keep it short and to the point. -22.54. In the year 1999, what is the difference between the Completion rate(% of total enrollments) in Belarus and Completion rate(% of total enrollments) in Czech Republic?
Offer a very short reply. -3.37. In the year 1999, what is the difference between the Completion rate(% of total enrollments) of Belarus and Completion rate(% of total enrollments) of Oman?
Ensure brevity in your answer.  11.74. In the year 1999, what is the difference between the Completion rate(% of total enrollments) in Belarus and Completion rate(% of total enrollments) in Ukraine?
Keep it short and to the point. 2.14. In the year 1999, what is the difference between the Completion rate(% of total enrollments) of Czech Republic and Completion rate(% of total enrollments) of Oman?
Provide a short and direct response. 15.11. In the year 1999, what is the difference between the Completion rate(% of total enrollments) of Czech Republic and Completion rate(% of total enrollments) of Ukraine?
Offer a very short reply. 5.51. In the year 1999, what is the difference between the Completion rate(% of total enrollments) of Oman and Completion rate(% of total enrollments) of Ukraine?
Your answer should be compact. -9.6. In the year 2000, what is the difference between the Completion rate(% of total enrollments) in Belarus and Completion rate(% of total enrollments) in Czech Republic?
Your answer should be compact. 0.77. In the year 2000, what is the difference between the Completion rate(% of total enrollments) of Belarus and Completion rate(% of total enrollments) of Oman?
Your answer should be compact. 16.48. In the year 2000, what is the difference between the Completion rate(% of total enrollments) of Belarus and Completion rate(% of total enrollments) of Ukraine?
Your answer should be compact. 8.59. In the year 2000, what is the difference between the Completion rate(% of total enrollments) of Czech Republic and Completion rate(% of total enrollments) of Oman?
Ensure brevity in your answer.  15.7. In the year 2000, what is the difference between the Completion rate(% of total enrollments) in Czech Republic and Completion rate(% of total enrollments) in Ukraine?
Keep it short and to the point. 7.81. In the year 2000, what is the difference between the Completion rate(% of total enrollments) in Oman and Completion rate(% of total enrollments) in Ukraine?
Ensure brevity in your answer.  -7.89. In the year 2001, what is the difference between the Completion rate(% of total enrollments) of Belarus and Completion rate(% of total enrollments) of Czech Republic?
Your response must be concise. 5.62. In the year 2001, what is the difference between the Completion rate(% of total enrollments) of Belarus and Completion rate(% of total enrollments) of Oman?
Provide a short and direct response. 19.6. In the year 2001, what is the difference between the Completion rate(% of total enrollments) of Belarus and Completion rate(% of total enrollments) of Ukraine?
Offer a terse response. 9. In the year 2001, what is the difference between the Completion rate(% of total enrollments) in Czech Republic and Completion rate(% of total enrollments) in Oman?
Your response must be concise. 13.98. In the year 2001, what is the difference between the Completion rate(% of total enrollments) of Czech Republic and Completion rate(% of total enrollments) of Ukraine?
Your response must be concise. 3.38. In the year 2001, what is the difference between the Completion rate(% of total enrollments) in Oman and Completion rate(% of total enrollments) in Ukraine?
Provide a succinct answer. -10.6. In the year 2002, what is the difference between the Completion rate(% of total enrollments) of Belarus and Completion rate(% of total enrollments) of Czech Republic?
Ensure brevity in your answer.  27.35. In the year 2002, what is the difference between the Completion rate(% of total enrollments) of Belarus and Completion rate(% of total enrollments) of Oman?
Make the answer very short. 42.68. In the year 2002, what is the difference between the Completion rate(% of total enrollments) in Belarus and Completion rate(% of total enrollments) in Ukraine?
Ensure brevity in your answer.  32.36. In the year 2002, what is the difference between the Completion rate(% of total enrollments) of Czech Republic and Completion rate(% of total enrollments) of Oman?
Your answer should be compact. 15.33. In the year 2002, what is the difference between the Completion rate(% of total enrollments) in Czech Republic and Completion rate(% of total enrollments) in Ukraine?
Your answer should be very brief. 5.01. In the year 2002, what is the difference between the Completion rate(% of total enrollments) of Oman and Completion rate(% of total enrollments) of Ukraine?
Your response must be concise. -10.31. In the year 2009, what is the difference between the Completion rate(% of total enrollments) of Belarus and Completion rate(% of total enrollments) of Czech Republic?
Make the answer very short. -0.94. In the year 2009, what is the difference between the Completion rate(% of total enrollments) in Belarus and Completion rate(% of total enrollments) in Oman?
Your answer should be compact. 11.51. In the year 2009, what is the difference between the Completion rate(% of total enrollments) of Belarus and Completion rate(% of total enrollments) of Ukraine?
Offer a terse response. 8.69. In the year 2009, what is the difference between the Completion rate(% of total enrollments) in Czech Republic and Completion rate(% of total enrollments) in Oman?
Your answer should be very brief. 12.45. In the year 2009, what is the difference between the Completion rate(% of total enrollments) in Czech Republic and Completion rate(% of total enrollments) in Ukraine?
Give a very brief answer. 9.63. In the year 2009, what is the difference between the Completion rate(% of total enrollments) of Oman and Completion rate(% of total enrollments) of Ukraine?
Give a very brief answer. -2.82. In the year 2011, what is the difference between the Completion rate(% of total enrollments) in Belarus and Completion rate(% of total enrollments) in Czech Republic?
Provide a succinct answer. 1.05. In the year 2011, what is the difference between the Completion rate(% of total enrollments) of Belarus and Completion rate(% of total enrollments) of Oman?
Your answer should be compact. 6.03. In the year 2011, what is the difference between the Completion rate(% of total enrollments) in Belarus and Completion rate(% of total enrollments) in Ukraine?
Make the answer very short. 6.2. In the year 2011, what is the difference between the Completion rate(% of total enrollments) of Czech Republic and Completion rate(% of total enrollments) of Oman?
Keep it short and to the point. 4.98. In the year 2011, what is the difference between the Completion rate(% of total enrollments) of Czech Republic and Completion rate(% of total enrollments) of Ukraine?
Offer a very short reply. 5.15. In the year 2011, what is the difference between the Completion rate(% of total enrollments) of Oman and Completion rate(% of total enrollments) of Ukraine?
Your answer should be very brief. 0.17. In the year 2012, what is the difference between the Completion rate(% of total enrollments) in Belarus and Completion rate(% of total enrollments) in Czech Republic?
Offer a terse response. 0.8. In the year 2012, what is the difference between the Completion rate(% of total enrollments) in Belarus and Completion rate(% of total enrollments) in Oman?
Your answer should be very brief. -0.45. In the year 2012, what is the difference between the Completion rate(% of total enrollments) of Belarus and Completion rate(% of total enrollments) of Ukraine?
Your answer should be compact. 0.49. In the year 2012, what is the difference between the Completion rate(% of total enrollments) in Czech Republic and Completion rate(% of total enrollments) in Oman?
Provide a succinct answer. -1.25. In the year 2012, what is the difference between the Completion rate(% of total enrollments) in Czech Republic and Completion rate(% of total enrollments) in Ukraine?
Your answer should be very brief. -0.31. In the year 2012, what is the difference between the Completion rate(% of total enrollments) of Oman and Completion rate(% of total enrollments) of Ukraine?
Your answer should be compact. 0.95. What is the ratio of the Completion rate(% of total enrollments) of Belarus in 1994 to that in 1999?
Make the answer very short. 1.01. What is the ratio of the Completion rate(% of total enrollments) in Czech Republic in 1994 to that in 1999?
Your response must be concise. 1.06. What is the ratio of the Completion rate(% of total enrollments) of Oman in 1994 to that in 1999?
Keep it short and to the point. 0.85. What is the ratio of the Completion rate(% of total enrollments) of Belarus in 1994 to that in 2000?
Keep it short and to the point. 0.97. What is the ratio of the Completion rate(% of total enrollments) in Czech Republic in 1994 to that in 2000?
Your answer should be very brief. 1.06. What is the ratio of the Completion rate(% of total enrollments) in Oman in 1994 to that in 2000?
Your response must be concise. 0.86. What is the ratio of the Completion rate(% of total enrollments) of Ukraine in 1994 to that in 2000?
Give a very brief answer. 1.03. What is the ratio of the Completion rate(% of total enrollments) in Belarus in 1994 to that in 2001?
Ensure brevity in your answer.  0.92. What is the ratio of the Completion rate(% of total enrollments) in Czech Republic in 1994 to that in 2001?
Your response must be concise. 1.07. What is the ratio of the Completion rate(% of total enrollments) in Oman in 1994 to that in 2001?
Ensure brevity in your answer.  0.84. What is the ratio of the Completion rate(% of total enrollments) in Ukraine in 1994 to that in 2001?
Give a very brief answer. 0.99. What is the ratio of the Completion rate(% of total enrollments) in Belarus in 1994 to that in 2002?
Your response must be concise. 0.74. What is the ratio of the Completion rate(% of total enrollments) in Czech Republic in 1994 to that in 2002?
Offer a very short reply. 1.02. What is the ratio of the Completion rate(% of total enrollments) of Oman in 1994 to that in 2002?
Give a very brief answer. 0.82. What is the ratio of the Completion rate(% of total enrollments) in Ukraine in 1994 to that in 2002?
Ensure brevity in your answer.  0.96. What is the ratio of the Completion rate(% of total enrollments) of Belarus in 1994 to that in 2009?
Make the answer very short. 0.92. What is the ratio of the Completion rate(% of total enrollments) of Oman in 1994 to that in 2009?
Provide a short and direct response. 0.77. What is the ratio of the Completion rate(% of total enrollments) of Ukraine in 1994 to that in 2009?
Give a very brief answer. 0.98. What is the ratio of the Completion rate(% of total enrollments) in Belarus in 1994 to that in 2011?
Your answer should be very brief. 0.91. What is the ratio of the Completion rate(% of total enrollments) in Czech Republic in 1994 to that in 2011?
Ensure brevity in your answer.  1. What is the ratio of the Completion rate(% of total enrollments) in Oman in 1994 to that in 2011?
Give a very brief answer. 0.71. What is the ratio of the Completion rate(% of total enrollments) of Ukraine in 1994 to that in 2011?
Give a very brief answer. 0.94. What is the ratio of the Completion rate(% of total enrollments) in Belarus in 1994 to that in 2012?
Provide a succinct answer. 0.94. What is the ratio of the Completion rate(% of total enrollments) in Czech Republic in 1994 to that in 2012?
Make the answer very short. 1.03. What is the ratio of the Completion rate(% of total enrollments) of Oman in 1994 to that in 2012?
Ensure brevity in your answer.  0.69. What is the ratio of the Completion rate(% of total enrollments) in Ukraine in 1994 to that in 2012?
Ensure brevity in your answer.  0.92. What is the ratio of the Completion rate(% of total enrollments) in Belarus in 1999 to that in 2000?
Your response must be concise. 0.96. What is the ratio of the Completion rate(% of total enrollments) in Oman in 1999 to that in 2000?
Give a very brief answer. 1.01. What is the ratio of the Completion rate(% of total enrollments) of Ukraine in 1999 to that in 2000?
Give a very brief answer. 1.03. What is the ratio of the Completion rate(% of total enrollments) of Belarus in 1999 to that in 2001?
Your response must be concise. 0.92. What is the ratio of the Completion rate(% of total enrollments) of Czech Republic in 1999 to that in 2001?
Ensure brevity in your answer.  1.01. What is the ratio of the Completion rate(% of total enrollments) in Ukraine in 1999 to that in 2001?
Offer a terse response. 0.98. What is the ratio of the Completion rate(% of total enrollments) in Belarus in 1999 to that in 2002?
Provide a succinct answer. 0.74. What is the ratio of the Completion rate(% of total enrollments) in Czech Republic in 1999 to that in 2002?
Ensure brevity in your answer.  0.96. What is the ratio of the Completion rate(% of total enrollments) in Oman in 1999 to that in 2002?
Your answer should be very brief. 0.96. What is the ratio of the Completion rate(% of total enrollments) of Ukraine in 1999 to that in 2002?
Keep it short and to the point. 0.96. What is the ratio of the Completion rate(% of total enrollments) in Belarus in 1999 to that in 2009?
Your response must be concise. 0.92. What is the ratio of the Completion rate(% of total enrollments) of Czech Republic in 1999 to that in 2009?
Give a very brief answer. 0.94. What is the ratio of the Completion rate(% of total enrollments) in Oman in 1999 to that in 2009?
Your answer should be compact. 0.91. What is the ratio of the Completion rate(% of total enrollments) in Ukraine in 1999 to that in 2009?
Make the answer very short. 0.98. What is the ratio of the Completion rate(% of total enrollments) in Belarus in 1999 to that in 2011?
Offer a very short reply. 0.9. What is the ratio of the Completion rate(% of total enrollments) in Czech Republic in 1999 to that in 2011?
Your response must be concise. 0.94. What is the ratio of the Completion rate(% of total enrollments) of Oman in 1999 to that in 2011?
Give a very brief answer. 0.84. What is the ratio of the Completion rate(% of total enrollments) of Ukraine in 1999 to that in 2011?
Your response must be concise. 0.93. What is the ratio of the Completion rate(% of total enrollments) of Belarus in 1999 to that in 2012?
Your answer should be very brief. 0.93. What is the ratio of the Completion rate(% of total enrollments) of Czech Republic in 1999 to that in 2012?
Make the answer very short. 0.97. What is the ratio of the Completion rate(% of total enrollments) of Oman in 1999 to that in 2012?
Give a very brief answer. 0.81. What is the ratio of the Completion rate(% of total enrollments) in Ukraine in 1999 to that in 2012?
Make the answer very short. 0.92. What is the ratio of the Completion rate(% of total enrollments) of Belarus in 2000 to that in 2001?
Provide a short and direct response. 0.95. What is the ratio of the Completion rate(% of total enrollments) in Czech Republic in 2000 to that in 2001?
Your answer should be very brief. 1. What is the ratio of the Completion rate(% of total enrollments) in Oman in 2000 to that in 2001?
Make the answer very short. 0.98. What is the ratio of the Completion rate(% of total enrollments) in Ukraine in 2000 to that in 2001?
Provide a short and direct response. 0.96. What is the ratio of the Completion rate(% of total enrollments) of Belarus in 2000 to that in 2002?
Provide a short and direct response. 0.77. What is the ratio of the Completion rate(% of total enrollments) of Czech Republic in 2000 to that in 2002?
Offer a very short reply. 0.96. What is the ratio of the Completion rate(% of total enrollments) of Oman in 2000 to that in 2002?
Provide a short and direct response. 0.95. What is the ratio of the Completion rate(% of total enrollments) in Ukraine in 2000 to that in 2002?
Keep it short and to the point. 0.93. What is the ratio of the Completion rate(% of total enrollments) of Belarus in 2000 to that in 2009?
Your answer should be very brief. 0.95. What is the ratio of the Completion rate(% of total enrollments) in Czech Republic in 2000 to that in 2009?
Provide a short and direct response. 0.94. What is the ratio of the Completion rate(% of total enrollments) in Oman in 2000 to that in 2009?
Make the answer very short. 0.89. What is the ratio of the Completion rate(% of total enrollments) in Ukraine in 2000 to that in 2009?
Provide a short and direct response. 0.95. What is the ratio of the Completion rate(% of total enrollments) in Belarus in 2000 to that in 2011?
Keep it short and to the point. 0.94. What is the ratio of the Completion rate(% of total enrollments) in Oman in 2000 to that in 2011?
Ensure brevity in your answer.  0.83. What is the ratio of the Completion rate(% of total enrollments) of Ukraine in 2000 to that in 2011?
Your response must be concise. 0.91. What is the ratio of the Completion rate(% of total enrollments) in Belarus in 2000 to that in 2012?
Provide a succinct answer. 0.97. What is the ratio of the Completion rate(% of total enrollments) in Czech Republic in 2000 to that in 2012?
Your response must be concise. 0.97. What is the ratio of the Completion rate(% of total enrollments) of Oman in 2000 to that in 2012?
Your answer should be compact. 0.8. What is the ratio of the Completion rate(% of total enrollments) of Ukraine in 2000 to that in 2012?
Your answer should be compact. 0.89. What is the ratio of the Completion rate(% of total enrollments) in Belarus in 2001 to that in 2002?
Your response must be concise. 0.8. What is the ratio of the Completion rate(% of total enrollments) in Czech Republic in 2001 to that in 2002?
Offer a very short reply. 0.96. What is the ratio of the Completion rate(% of total enrollments) in Oman in 2001 to that in 2002?
Make the answer very short. 0.97. What is the ratio of the Completion rate(% of total enrollments) of Ukraine in 2001 to that in 2002?
Make the answer very short. 0.97. What is the ratio of the Completion rate(% of total enrollments) in Belarus in 2001 to that in 2009?
Make the answer very short. 1. What is the ratio of the Completion rate(% of total enrollments) in Czech Republic in 2001 to that in 2009?
Make the answer very short. 0.94. What is the ratio of the Completion rate(% of total enrollments) in Oman in 2001 to that in 2009?
Ensure brevity in your answer.  0.91. What is the ratio of the Completion rate(% of total enrollments) of Ukraine in 2001 to that in 2009?
Make the answer very short. 1. What is the ratio of the Completion rate(% of total enrollments) in Belarus in 2001 to that in 2011?
Your answer should be very brief. 0.98. What is the ratio of the Completion rate(% of total enrollments) of Czech Republic in 2001 to that in 2011?
Make the answer very short. 0.94. What is the ratio of the Completion rate(% of total enrollments) in Oman in 2001 to that in 2011?
Ensure brevity in your answer.  0.84. What is the ratio of the Completion rate(% of total enrollments) in Ukraine in 2001 to that in 2011?
Offer a very short reply. 0.95. What is the ratio of the Completion rate(% of total enrollments) in Belarus in 2001 to that in 2012?
Provide a succinct answer. 1.01. What is the ratio of the Completion rate(% of total enrollments) in Czech Republic in 2001 to that in 2012?
Provide a succinct answer. 0.97. What is the ratio of the Completion rate(% of total enrollments) in Oman in 2001 to that in 2012?
Make the answer very short. 0.82. What is the ratio of the Completion rate(% of total enrollments) of Ukraine in 2001 to that in 2012?
Provide a short and direct response. 0.93. What is the ratio of the Completion rate(% of total enrollments) in Belarus in 2002 to that in 2009?
Your response must be concise. 1.25. What is the ratio of the Completion rate(% of total enrollments) of Czech Republic in 2002 to that in 2009?
Offer a terse response. 0.98. What is the ratio of the Completion rate(% of total enrollments) in Oman in 2002 to that in 2009?
Your answer should be compact. 0.94. What is the ratio of the Completion rate(% of total enrollments) in Ukraine in 2002 to that in 2009?
Your answer should be very brief. 1.02. What is the ratio of the Completion rate(% of total enrollments) of Belarus in 2002 to that in 2011?
Offer a terse response. 1.22. What is the ratio of the Completion rate(% of total enrollments) in Czech Republic in 2002 to that in 2011?
Your response must be concise. 0.98. What is the ratio of the Completion rate(% of total enrollments) of Oman in 2002 to that in 2011?
Your answer should be very brief. 0.87. What is the ratio of the Completion rate(% of total enrollments) in Ukraine in 2002 to that in 2011?
Your answer should be compact. 0.98. What is the ratio of the Completion rate(% of total enrollments) in Belarus in 2002 to that in 2012?
Your answer should be compact. 1.26. What is the ratio of the Completion rate(% of total enrollments) of Czech Republic in 2002 to that in 2012?
Keep it short and to the point. 1.01. What is the ratio of the Completion rate(% of total enrollments) of Oman in 2002 to that in 2012?
Your answer should be compact. 0.85. What is the ratio of the Completion rate(% of total enrollments) in Ukraine in 2002 to that in 2012?
Make the answer very short. 0.96. What is the ratio of the Completion rate(% of total enrollments) in Belarus in 2009 to that in 2011?
Keep it short and to the point. 0.98. What is the ratio of the Completion rate(% of total enrollments) in Czech Republic in 2009 to that in 2011?
Keep it short and to the point. 1. What is the ratio of the Completion rate(% of total enrollments) in Oman in 2009 to that in 2011?
Provide a short and direct response. 0.93. What is the ratio of the Completion rate(% of total enrollments) of Ukraine in 2009 to that in 2011?
Give a very brief answer. 0.95. What is the ratio of the Completion rate(% of total enrollments) of Belarus in 2009 to that in 2012?
Offer a very short reply. 1.01. What is the ratio of the Completion rate(% of total enrollments) of Czech Republic in 2009 to that in 2012?
Your response must be concise. 1.03. What is the ratio of the Completion rate(% of total enrollments) in Oman in 2009 to that in 2012?
Give a very brief answer. 0.9. What is the ratio of the Completion rate(% of total enrollments) of Ukraine in 2009 to that in 2012?
Ensure brevity in your answer.  0.94. What is the ratio of the Completion rate(% of total enrollments) of Belarus in 2011 to that in 2012?
Offer a terse response. 1.03. What is the ratio of the Completion rate(% of total enrollments) in Czech Republic in 2011 to that in 2012?
Offer a terse response. 1.03. What is the ratio of the Completion rate(% of total enrollments) in Oman in 2011 to that in 2012?
Offer a very short reply. 0.97. What is the ratio of the Completion rate(% of total enrollments) in Ukraine in 2011 to that in 2012?
Offer a very short reply. 0.98. What is the difference between the highest and the second highest Completion rate(% of total enrollments) in Belarus?
Your response must be concise. 23.76. What is the difference between the highest and the second highest Completion rate(% of total enrollments) of Czech Republic?
Your answer should be compact. 0.06. What is the difference between the highest and the second highest Completion rate(% of total enrollments) in Oman?
Make the answer very short. 2.91. What is the difference between the highest and the second highest Completion rate(% of total enrollments) in Ukraine?
Your answer should be compact. 2.13. What is the difference between the highest and the lowest Completion rate(% of total enrollments) in Belarus?
Provide a short and direct response. 34.37. What is the difference between the highest and the lowest Completion rate(% of total enrollments) in Czech Republic?
Offer a terse response. 6.75. What is the difference between the highest and the lowest Completion rate(% of total enrollments) of Oman?
Provide a succinct answer. 31.99. What is the difference between the highest and the lowest Completion rate(% of total enrollments) in Ukraine?
Provide a short and direct response. 11.4. 